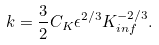Convert formula to latex. <formula><loc_0><loc_0><loc_500><loc_500>k = \frac { 3 } { 2 } C _ { K } \epsilon ^ { 2 / 3 } K _ { i n f } ^ { - 2 / 3 } .</formula> 